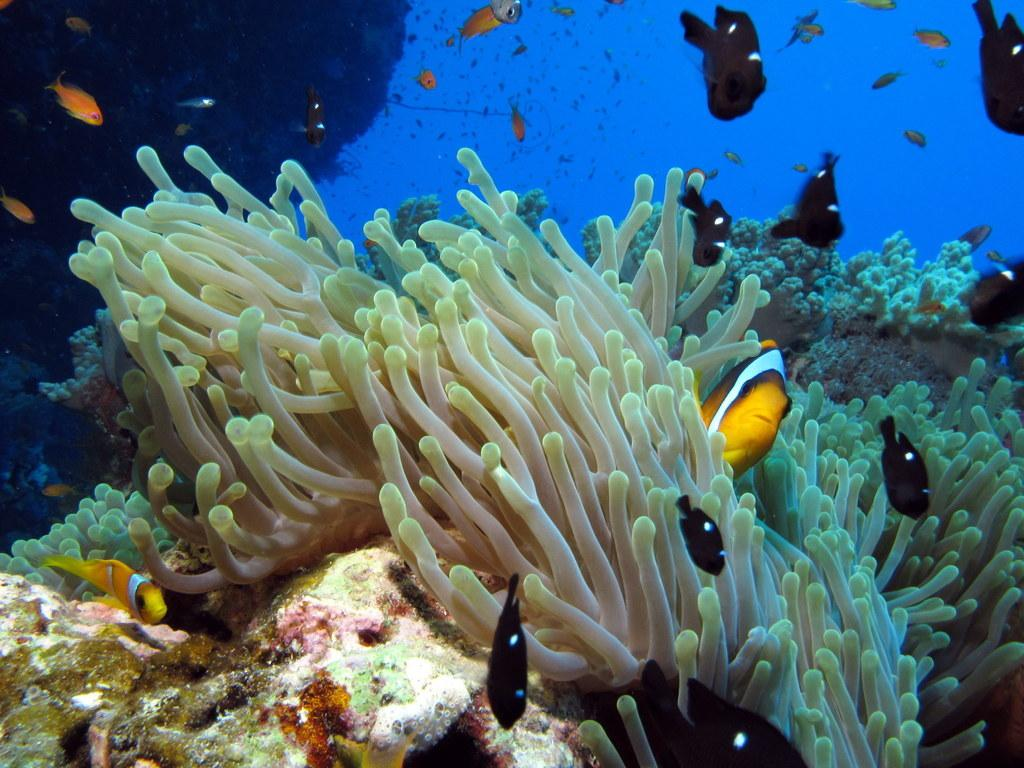What is the main subject of the image? The main subject of the image is an inside view of water. What can be seen in the water besides the water itself? There are sea plants and multiple fish visible in the image. How many toes can be seen in the image? There are no toes visible in the image, as it depicts an underwater scene with sea plants and fish. 